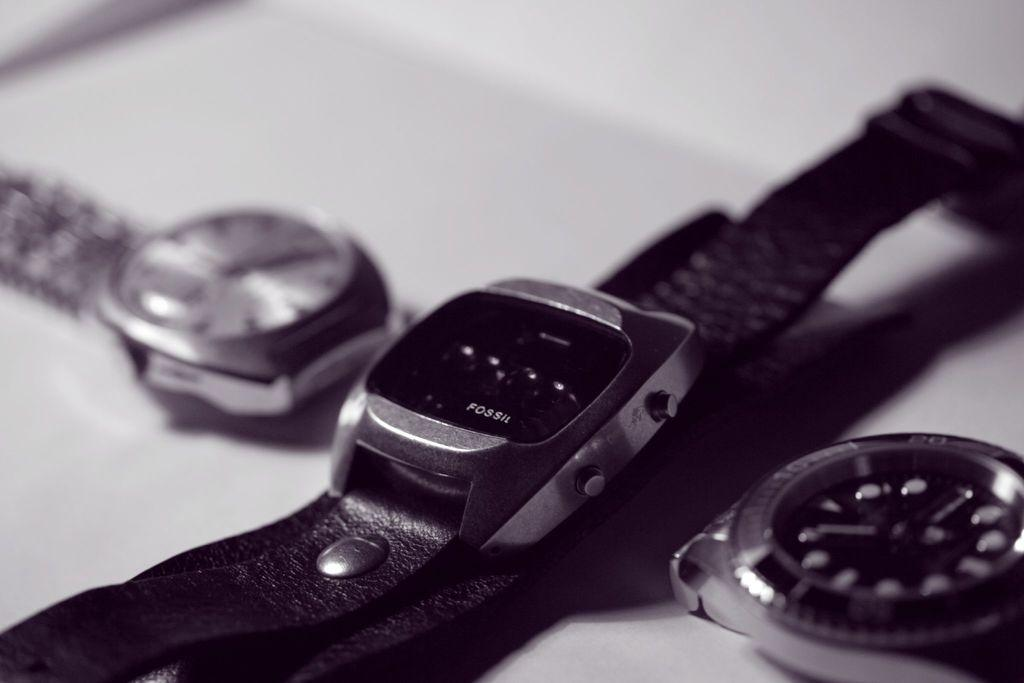<image>
Relay a brief, clear account of the picture shown. A black Fossil watch is laying on a table with 2 other watches. 